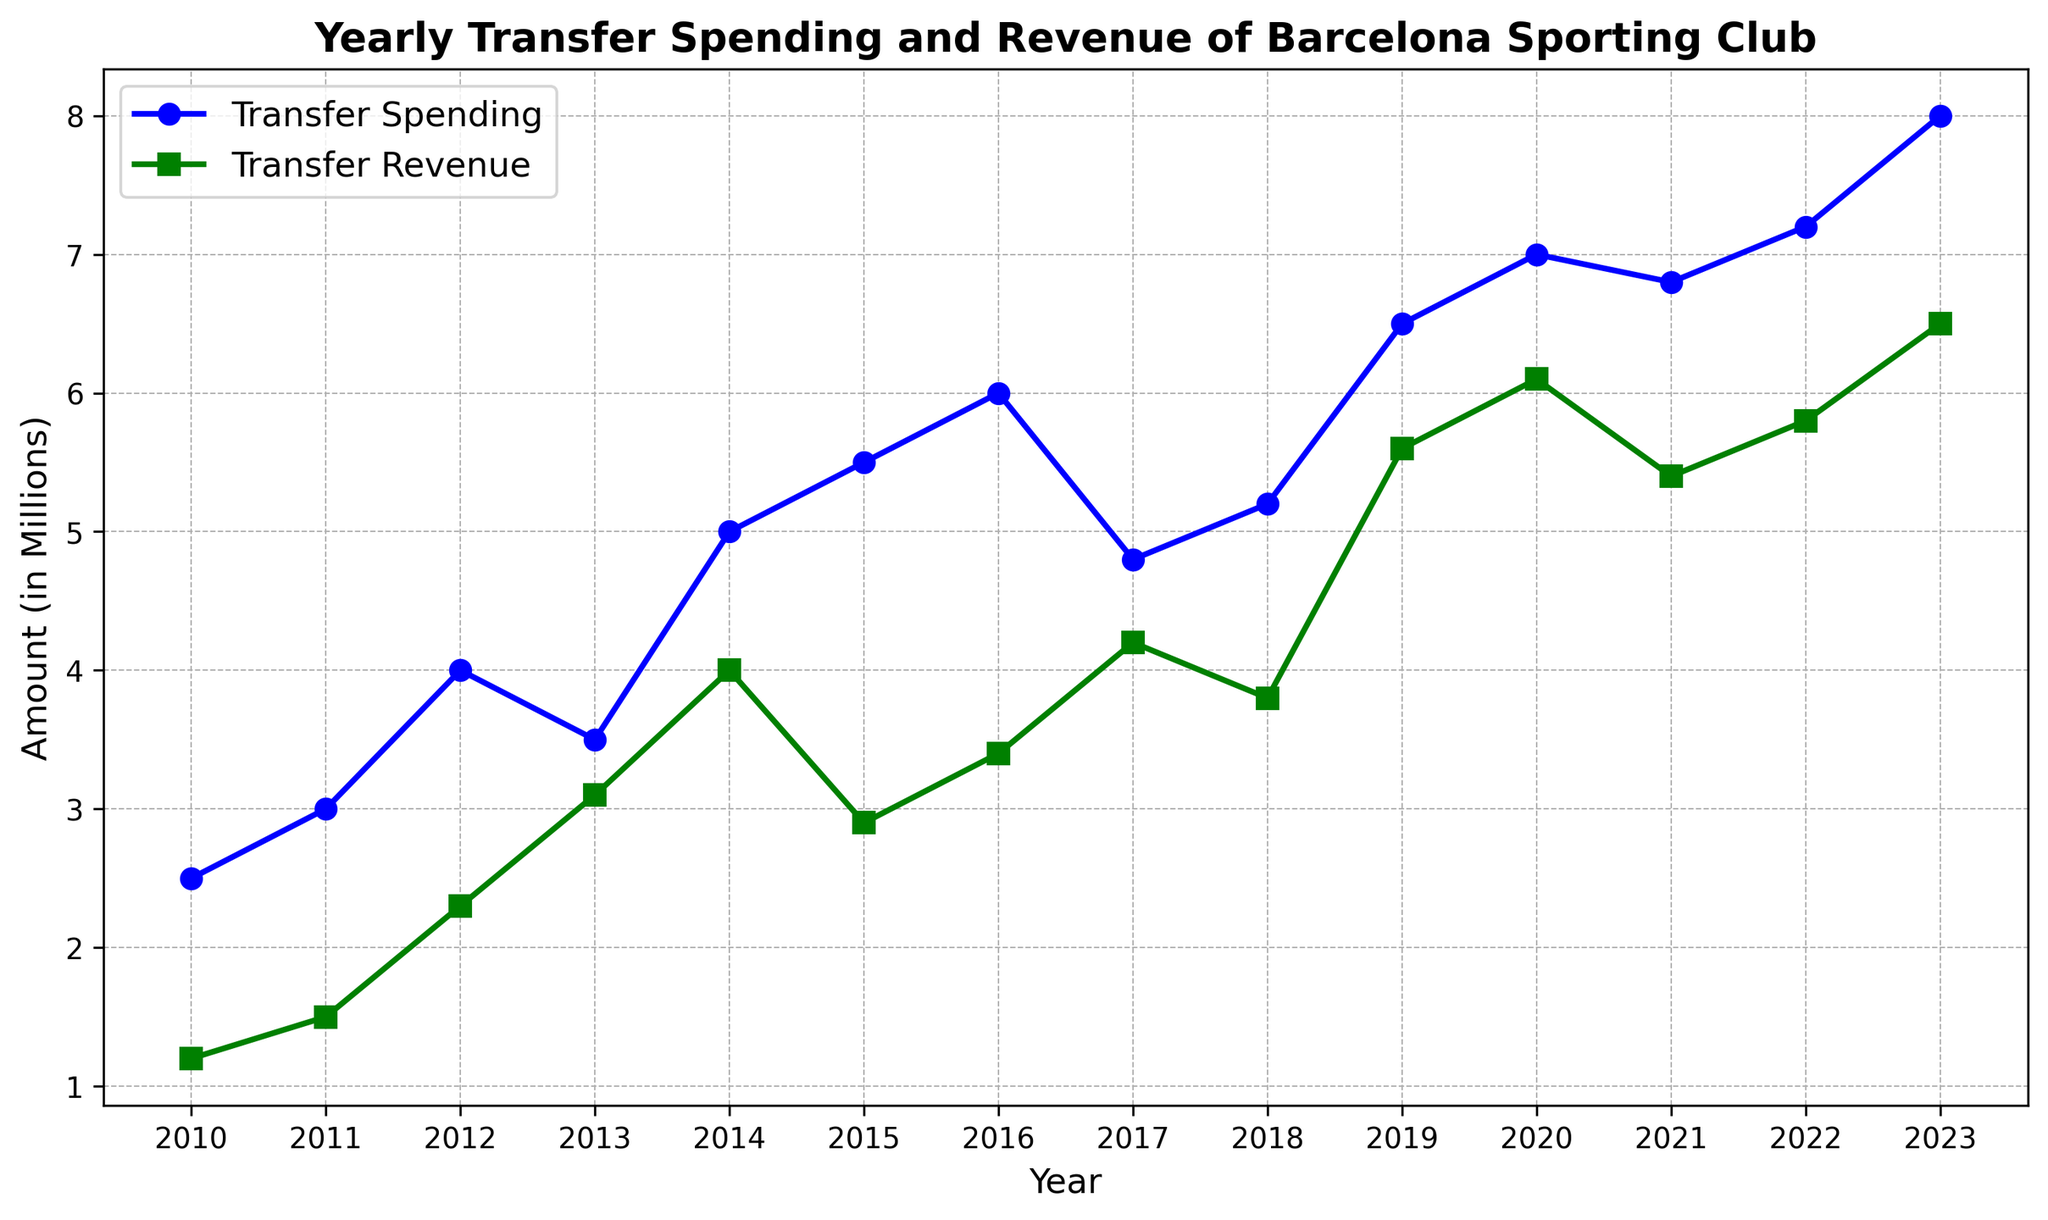What was the Transfer Spending in 2013 and how does it compare to the Transfer Revenue that year? According to the plot, Transfer Spending in 2013 was 3.5 million and Transfer Revenue was 3.1 million. By comparing the two, we can see that Transfer Spending was slightly higher by 0.4 million in 2013.
Answer: Transfer Spending was 0.4 million higher What was the difference between Transfer Spending and Transfer Revenue in 2020? In 2020, the Transfer Spending was 7.0 million and the Transfer Revenue was 6.1 million. The difference can be calculated as 7.0 - 6.1 = 0.9 million.
Answer: 0.9 million In which year did Transfer Spending first exceed 5 million? By looking at the trend of Transfer Spending, the first occurrence above 5 million happens in 2015.
Answer: 2015 How did Transfer Revenue change from 2011 to 2012? In 2011, the Transfer Revenue was 1.5 million and it increased to 2.3 million in 2012. The change is calculated as 2.3 - 1.5 = 0.8 million.
Answer: Increased by 0.8 million Which year experienced the greatest Transfer Spending, and what was the amount? According to the plot, the year with the highest Transfer Spending is 2023 with an amount of 8.0 million.
Answer: 2023, 8.0 million How did the trend of Transfer Revenue generally compare to Transfer Spending from 2010 to 2023? By analyzing the plot, although both Transfer Revenue and Transfer Spending show an upward trend, Transfer Spending is generally higher than Transfer Revenue throughout the years.
Answer: Transfer Spending is generally higher Identify the year with the smallest gap between Transfer Spending and Revenue, and state the gap. The smallest gap occurs in 2013, where the Transfer Spending was 3.5 million and Transfer Revenue was 3.1 million. The gap is 3.5 - 3.1 = 0.4 million.
Answer: 2013, 0.4 million What is the average Transfer Spending and Transfer Revenue from 2014 to 2018? From 2014 to 2018, Transfer Spending amounts to 5.0+5.5+6.0+4.8+5.2 = 26.5 million, and Transfer Revenue amounts to 4.0+2.9+3.4+4.2+3.8 = 18.3 million. The average Transfer Spending is 26.5/5 = 5.3 million, and the average Transfer Revenue is 18.3/5 = 3.66 million.
Answer: Average Transfer Spending: 5.3 million, Average Transfer Revenue: 3.66 million Did Transfer Revenue ever match or exceed Transfer Spending in any year? The plot shows that Transfer Revenue never matched or exceeded Transfer Spending in any of the years from 2010 to 2023.
Answer: No 